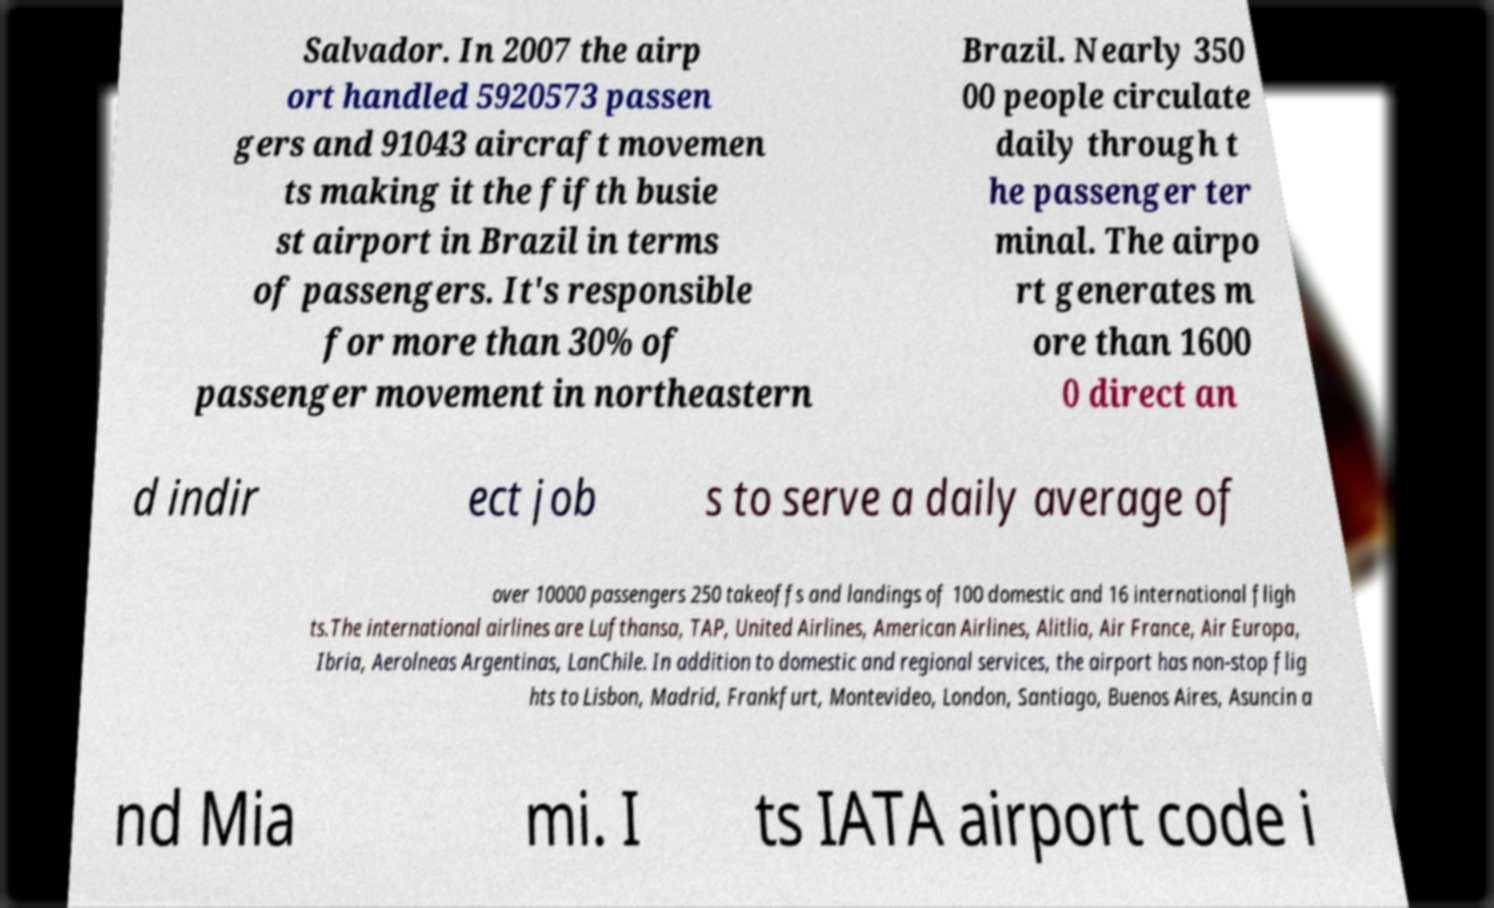Could you assist in decoding the text presented in this image and type it out clearly? Salvador. In 2007 the airp ort handled 5920573 passen gers and 91043 aircraft movemen ts making it the fifth busie st airport in Brazil in terms of passengers. It's responsible for more than 30% of passenger movement in northeastern Brazil. Nearly 350 00 people circulate daily through t he passenger ter minal. The airpo rt generates m ore than 1600 0 direct an d indir ect job s to serve a daily average of over 10000 passengers 250 takeoffs and landings of 100 domestic and 16 international fligh ts.The international airlines are Lufthansa, TAP, United Airlines, American Airlines, Alitlia, Air France, Air Europa, Ibria, Aerolneas Argentinas, LanChile. In addition to domestic and regional services, the airport has non-stop flig hts to Lisbon, Madrid, Frankfurt, Montevideo, London, Santiago, Buenos Aires, Asuncin a nd Mia mi. I ts IATA airport code i 